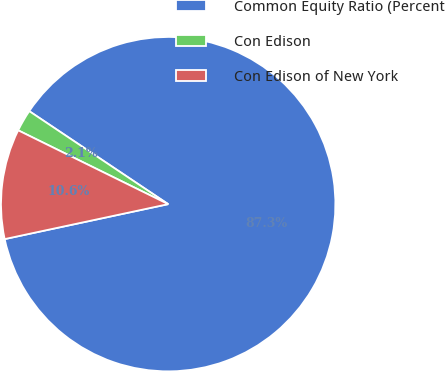<chart> <loc_0><loc_0><loc_500><loc_500><pie_chart><fcel>Common Equity Ratio (Percent<fcel>Con Edison<fcel>Con Edison of New York<nl><fcel>87.26%<fcel>2.11%<fcel>10.63%<nl></chart> 